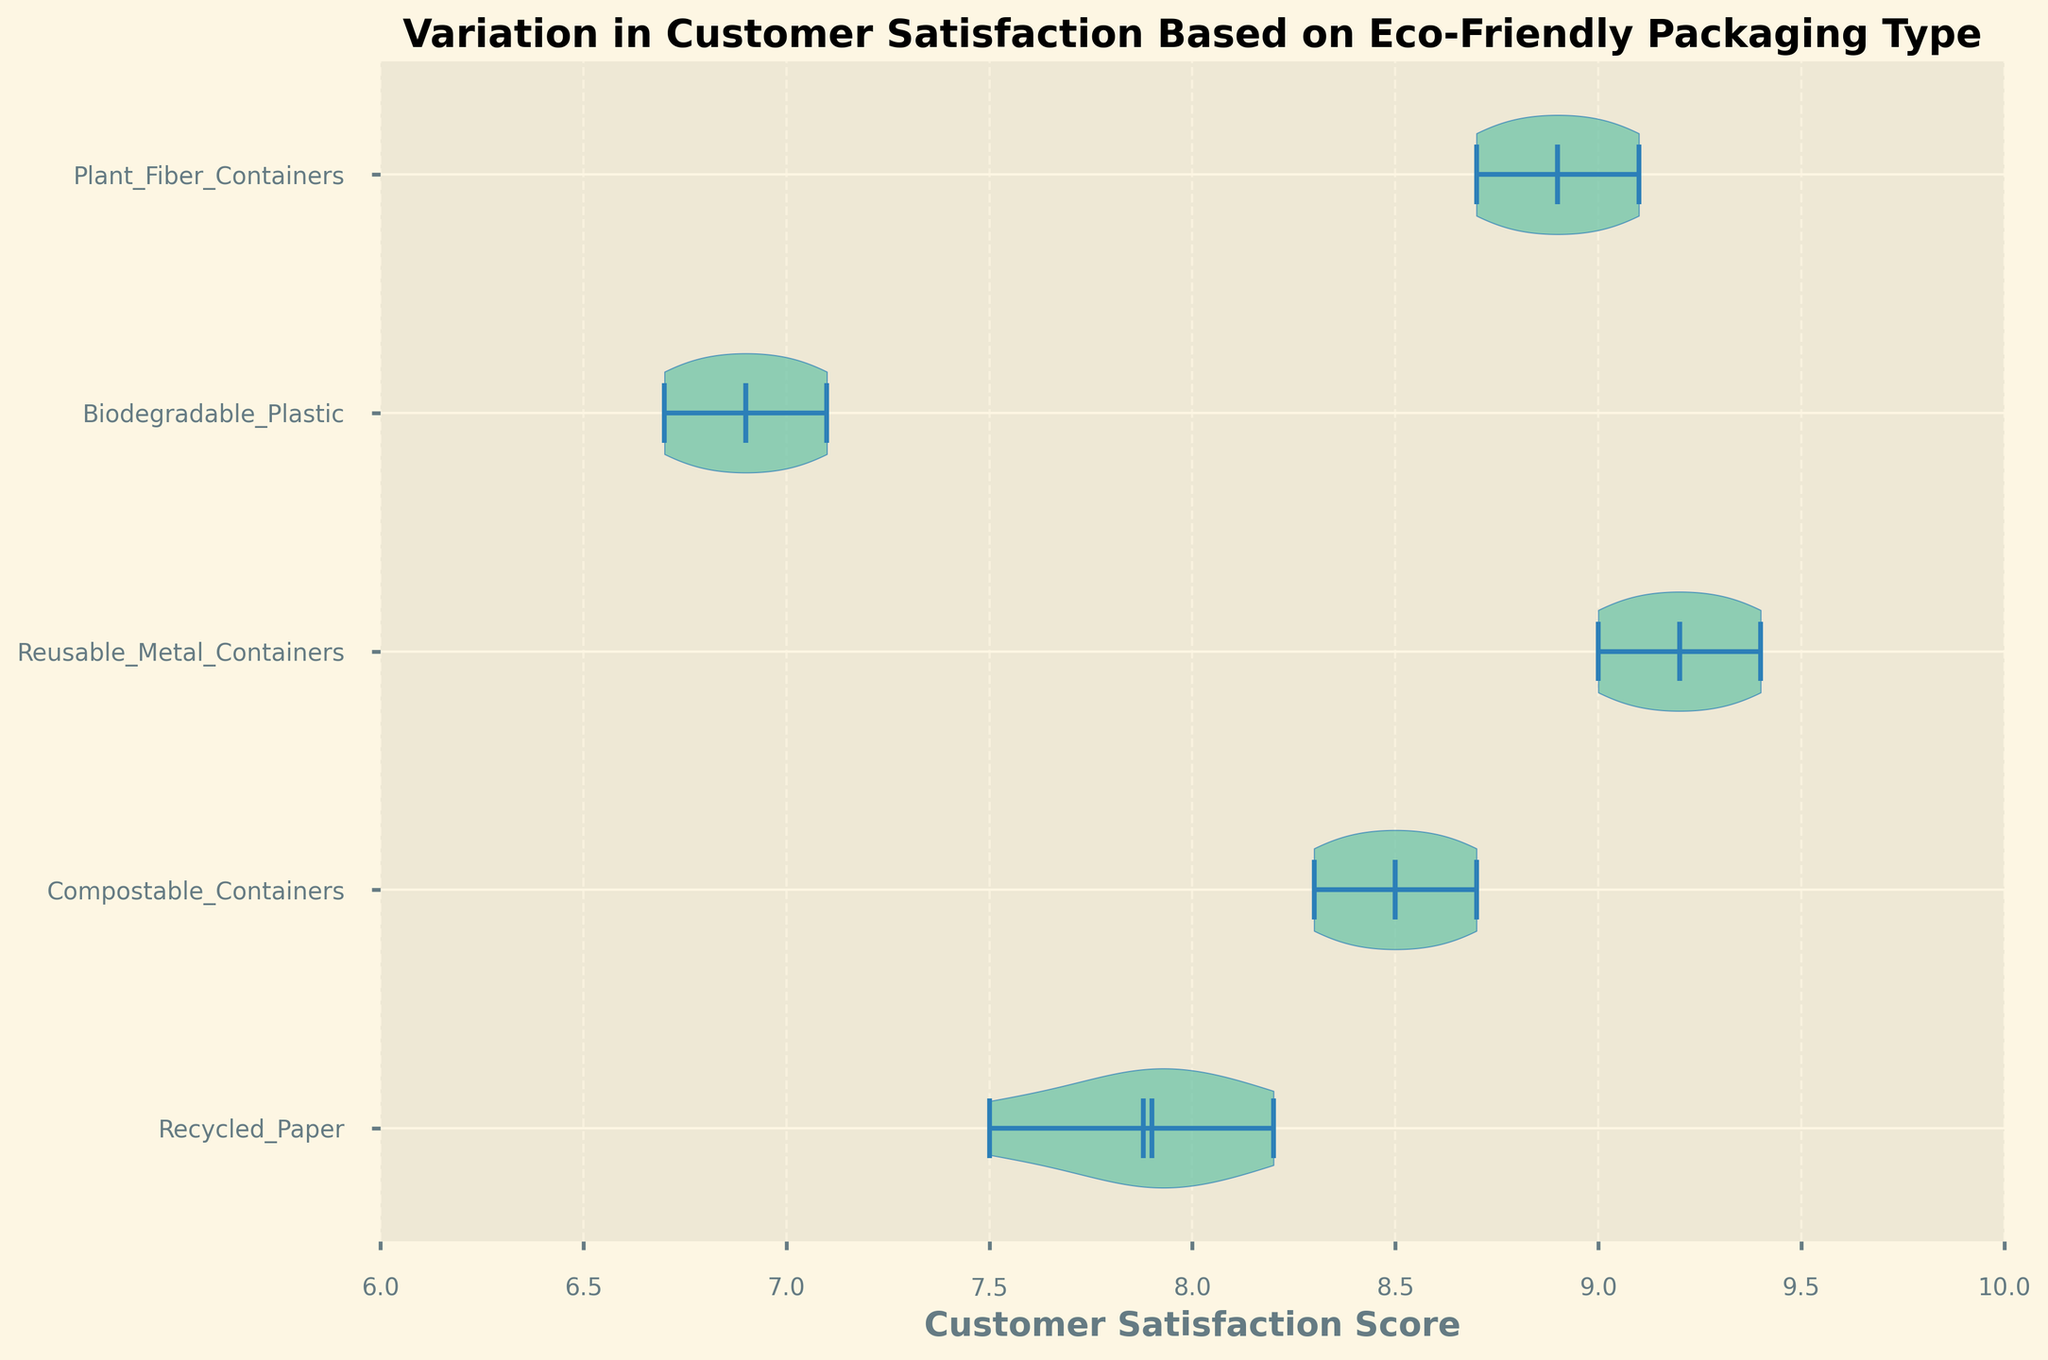What does the title of the chart say? The title is usually located at the top of the chart and it summarizes the main topic of the figure. In this case, it reads "Variation in Customer Satisfaction Based on Eco-Friendly Packaging Type".
Answer: Variation in Customer Satisfaction Based on Eco-Friendly Packaging Type How many different types of eco-friendly packaging are compared in the chart? The label for each type of eco-friendly packaging is given on the y-axis. Count the different labels to find the total number of types compared.
Answer: 5 Which eco-friendly packaging has the highest median customer satisfaction score? The median is typically represented by a horizontal line within the violin plot. Look for the plot with the median line furthest to the right.
Answer: Reusable Metal Containers Which packaging type shows the highest mean customer satisfaction score? The mean is usually represented by another symbol, like a point or a different line. Identify the packaging type with the mean furthest to the right.
Answer: Reusable Metal Containers What's the range of customer satisfaction scores for Biodegradable Plastic packaging? The range is determined by the minimum and maximum points of the violin plot. Identify these points for the Biodegradable Plastic violin.
Answer: 6.7 to 7.1 Which packaging has the widest spread in customer satisfaction scores? The spread is wider if the range between the minimum and maximum points is larger. Compare the spreads for all packaging types visually.
Answer: Plant Fiber Containers Between Recycled Paper and Compostable Containers, which has a higher minimum customer satisfaction score? Look at the minimum marks on the violin plots for Recycled Paper and Compostable Containers and determine which is higher.
Answer: Compostable Containers Do any packaging types have overlapping ranges of customer satisfaction scores? Which ones? Overlapping ranges can be identified by comparing the minimum and maximum values visually in the violin plots to see if they intersect.
Answer: Recycled Paper and Biodegradable Plastic What is the approximate mean customer satisfaction score for Plant Fiber Containers? The mean is indicated by a special mark, often a dot or another symbol, within the violin plot. Look for this mark within the Plant Fiber Containers plot.
Answer: 8.9 